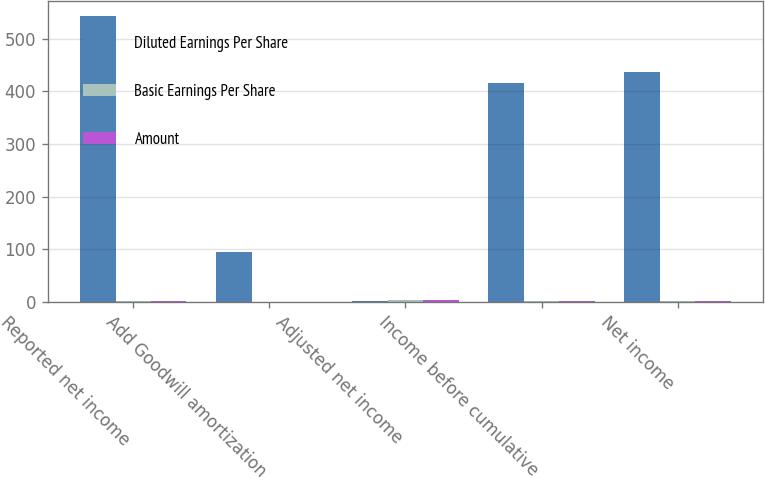<chart> <loc_0><loc_0><loc_500><loc_500><stacked_bar_chart><ecel><fcel>Reported net income<fcel>Add Goodwill amortization<fcel>Adjusted net income<fcel>Income before cumulative<fcel>Net income<nl><fcel>Diluted Earnings Per Share<fcel>544<fcel>95<fcel>2.16<fcel>415<fcel>436<nl><fcel>Basic Earnings Per Share<fcel>2.17<fcel>0.38<fcel>2.55<fcel>1.76<fcel>1.85<nl><fcel>Amount<fcel>2.15<fcel>0.38<fcel>2.53<fcel>1.76<fcel>1.85<nl></chart> 